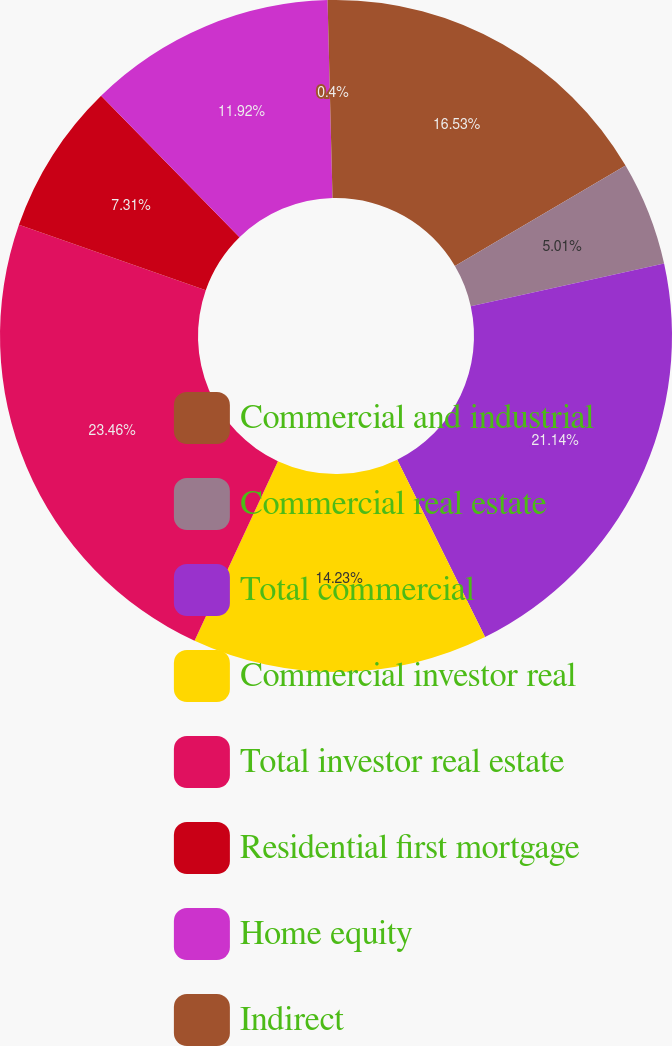Convert chart. <chart><loc_0><loc_0><loc_500><loc_500><pie_chart><fcel>Commercial and industrial<fcel>Commercial real estate<fcel>Total commercial<fcel>Commercial investor real<fcel>Total investor real estate<fcel>Residential first mortgage<fcel>Home equity<fcel>Indirect<nl><fcel>16.53%<fcel>5.01%<fcel>21.14%<fcel>14.23%<fcel>23.45%<fcel>7.31%<fcel>11.92%<fcel>0.4%<nl></chart> 